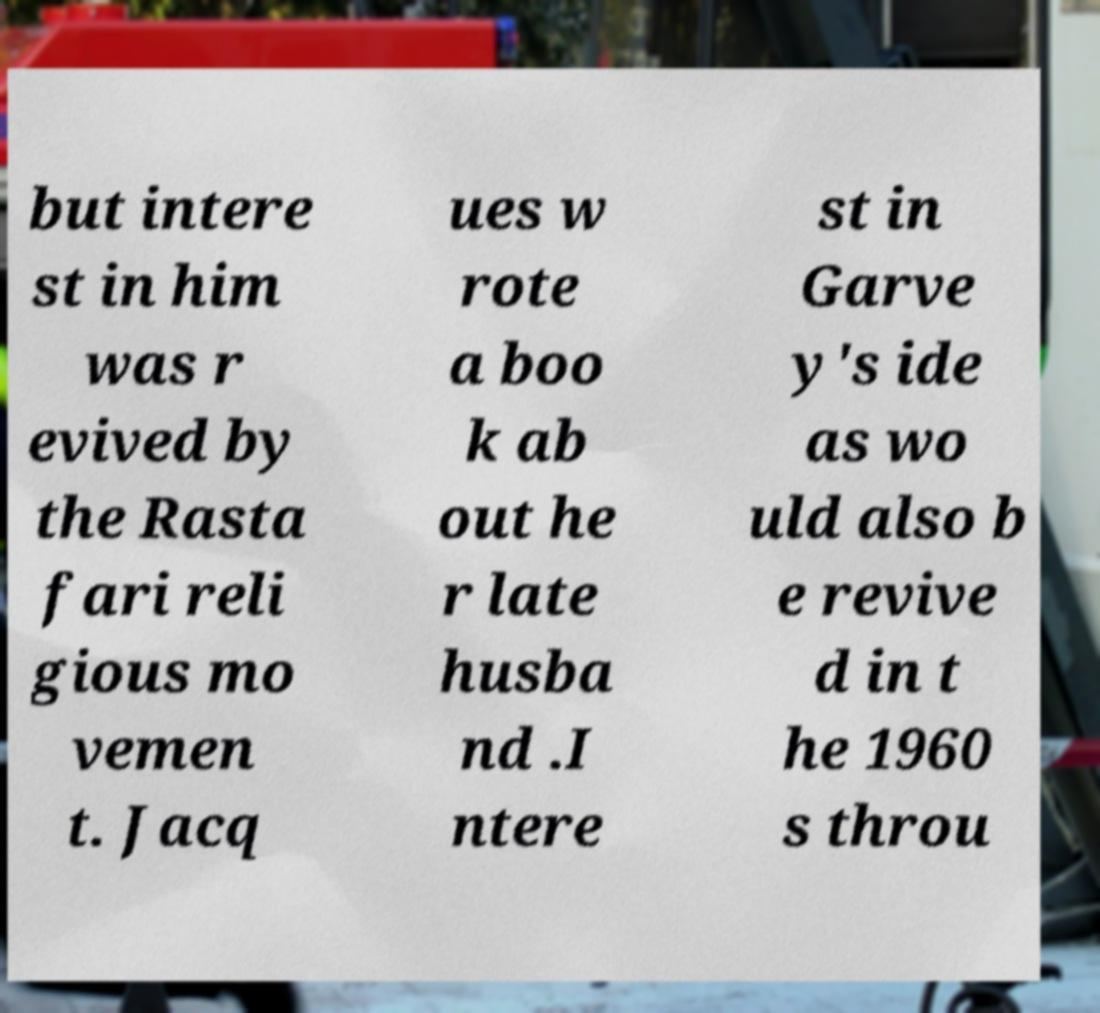Could you assist in decoding the text presented in this image and type it out clearly? but intere st in him was r evived by the Rasta fari reli gious mo vemen t. Jacq ues w rote a boo k ab out he r late husba nd .I ntere st in Garve y's ide as wo uld also b e revive d in t he 1960 s throu 